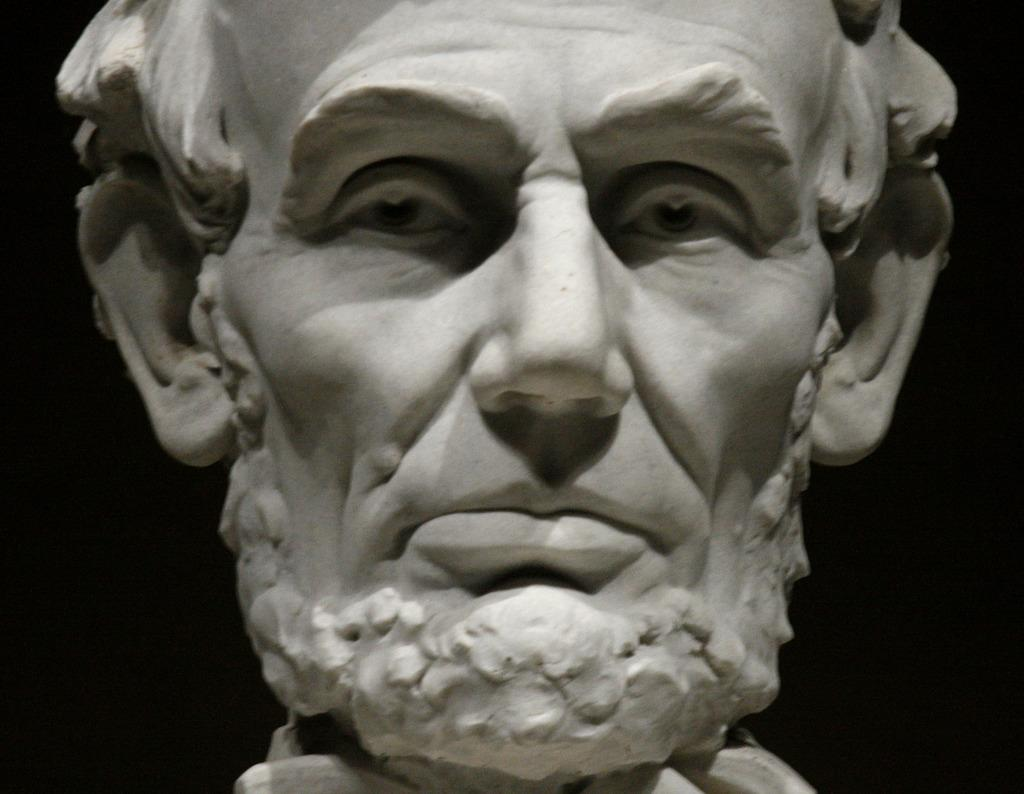What is the main subject of the image? The main subject of the image is a sculpture of a person. How is the sculpture depicted? The sculpture is truncated. What can be observed about the background of the image? The background of the image is dark. What is the sculpture's wealth status in the image? The sculpture does not have a wealth status, as it is an inanimate object and cannot possess wealth. 